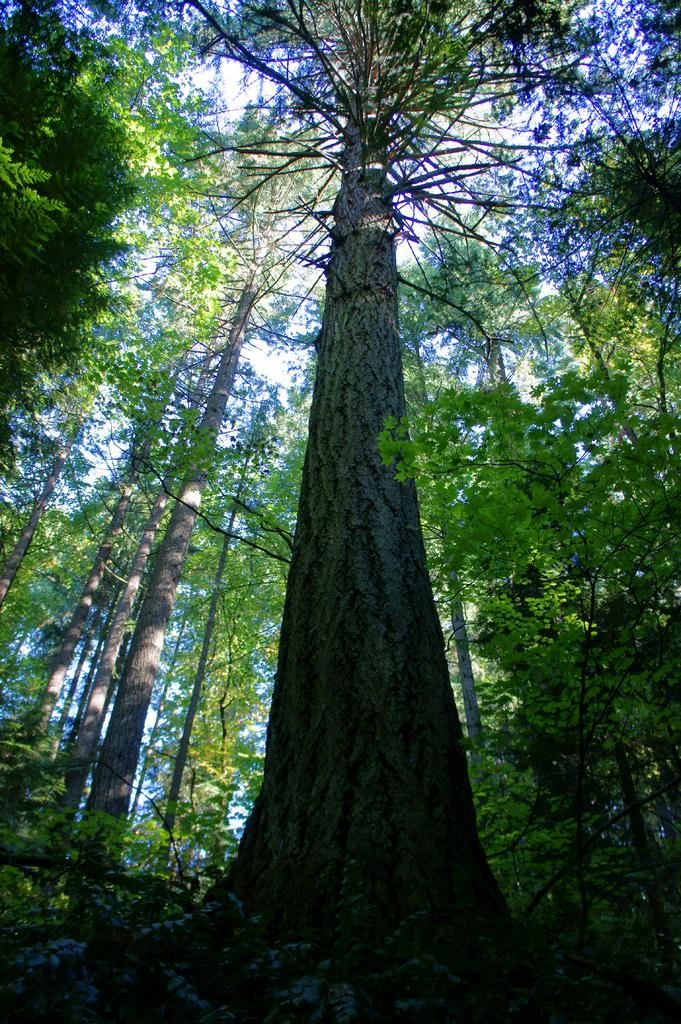What type of natural environment is depicted in the image? The image features many trees, suggesting a forest or wooded area. What can be seen in the sky in the image? The sky is visible in the image, but no specific details about the sky are provided. What type of music can be heard coming from the monkey in the image? There is no monkey present in the image, and therefore no music can be heard coming from it. 